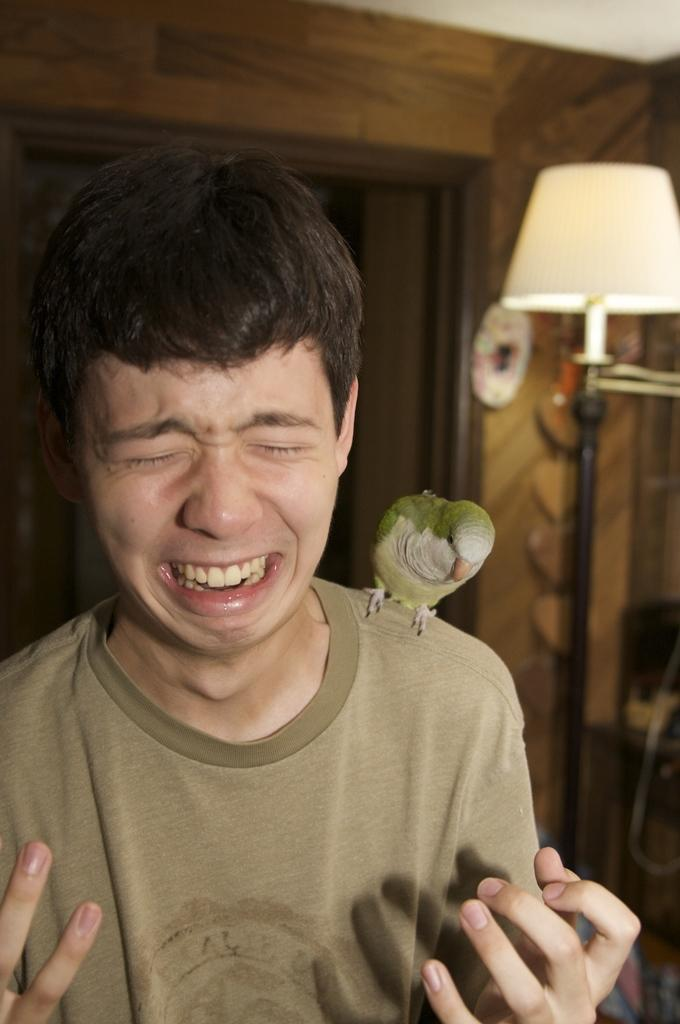What is the main subject of the image? There is a person standing in the middle of the image. What is the person doing in the image? The person is crying in the image. Is there any animal present in the image? Yes, there is a bird on the person's shoulder in the image. What can be seen behind the person? There is a wall and a lamp behind the person in the image. What color is the crayon that the person is using to draw in the morning in the image? There is no crayon or morning activity depicted in the image; the person is crying and there is a bird on their shoulder. 